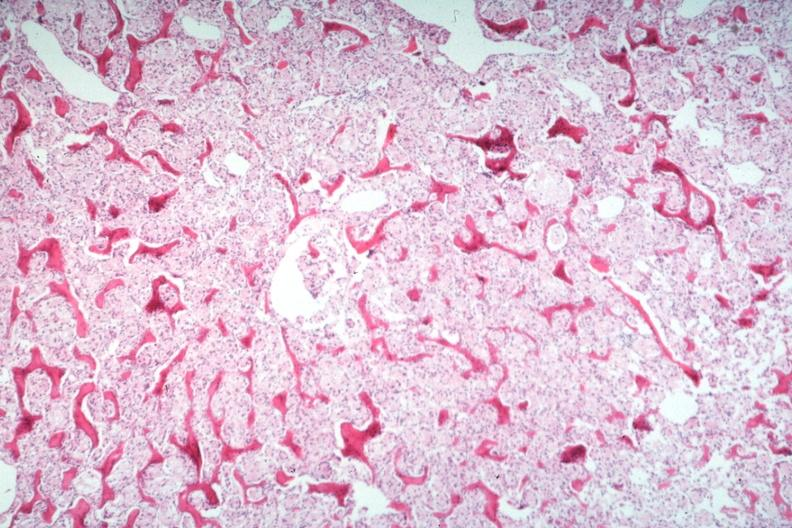does this image show stomach primary?
Answer the question using a single word or phrase. Yes 